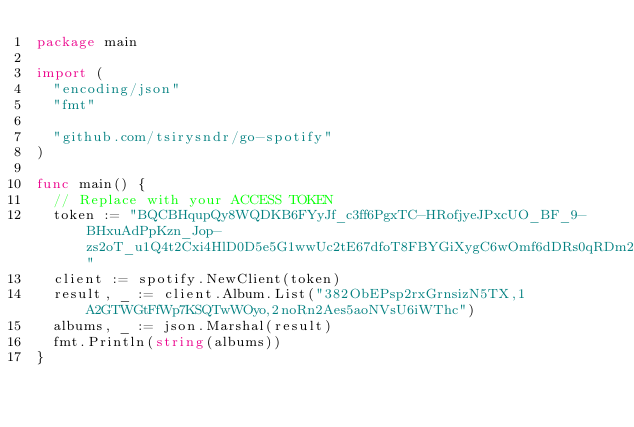<code> <loc_0><loc_0><loc_500><loc_500><_Go_>package main

import (
	"encoding/json"
	"fmt"

	"github.com/tsirysndr/go-spotify"
)

func main() {
	// Replace with your ACCESS TOKEN
	token := "BQCBHqupQy8WQDKB6FYyJf_c3ff6PgxTC-HRofjyeJPxcUO_BF_9-BHxuAdPpKzn_Jop-zs2oT_u1Q4t2Cxi4HlD0D5e5G1wwUc2tE67dfoT8FBYGiXygC6wOmf6dDRs0qRDm2qCsntoNLM9lnqe5XofaY2OCVAN0Q"
	client := spotify.NewClient(token)
	result, _ := client.Album.List("382ObEPsp2rxGrnsizN5TX,1A2GTWGtFfWp7KSQTwWOyo,2noRn2Aes5aoNVsU6iWThc")
	albums, _ := json.Marshal(result)
	fmt.Println(string(albums))
}
</code> 